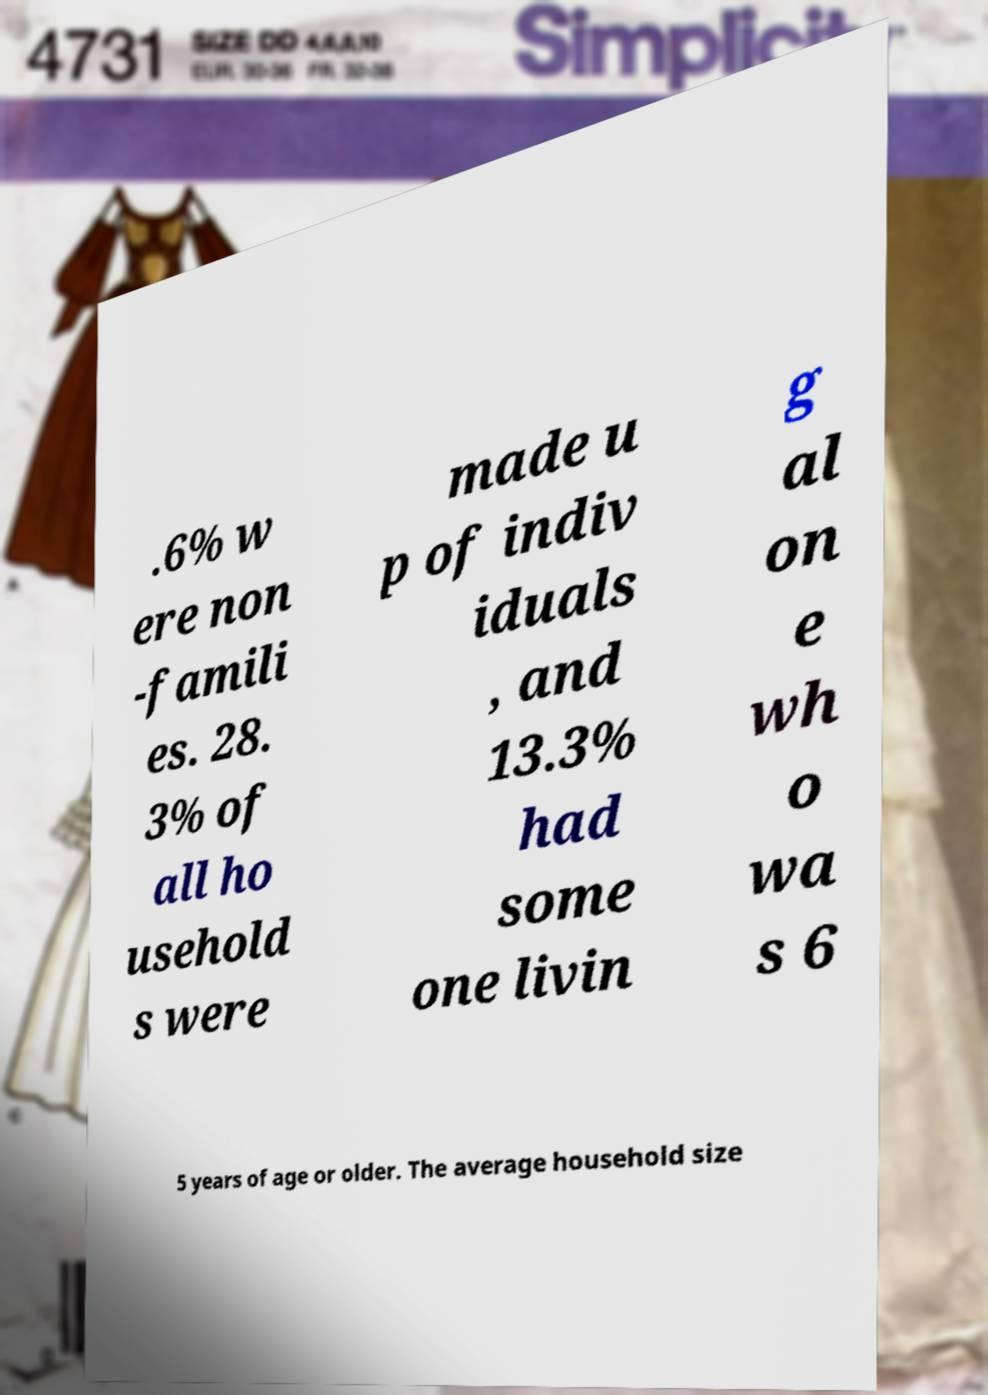Could you assist in decoding the text presented in this image and type it out clearly? .6% w ere non -famili es. 28. 3% of all ho usehold s were made u p of indiv iduals , and 13.3% had some one livin g al on e wh o wa s 6 5 years of age or older. The average household size 